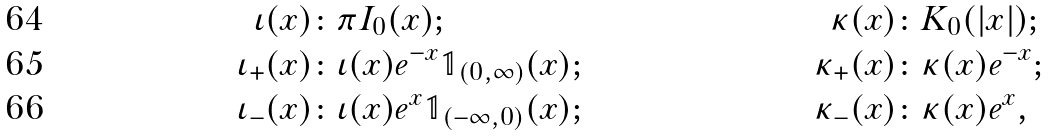Convert formula to latex. <formula><loc_0><loc_0><loc_500><loc_500>\iota ( x ) \colon & \pi I _ { 0 } ( x ) ; & \kappa ( x ) \colon & K _ { 0 } ( | x | ) ; \\ \iota _ { + } ( x ) \colon & \iota ( x ) e ^ { - x } \mathbb { 1 } _ { ( 0 , \infty ) } ( x ) ; & \kappa _ { + } ( x ) \colon & \kappa ( x ) e ^ { - x } ; \\ \iota _ { - } ( x ) \colon & \iota ( x ) e ^ { x } \mathbb { 1 } _ { ( - \infty , 0 ) } ( x ) ; & \kappa _ { - } ( x ) \colon & \kappa ( x ) e ^ { x } ,</formula> 